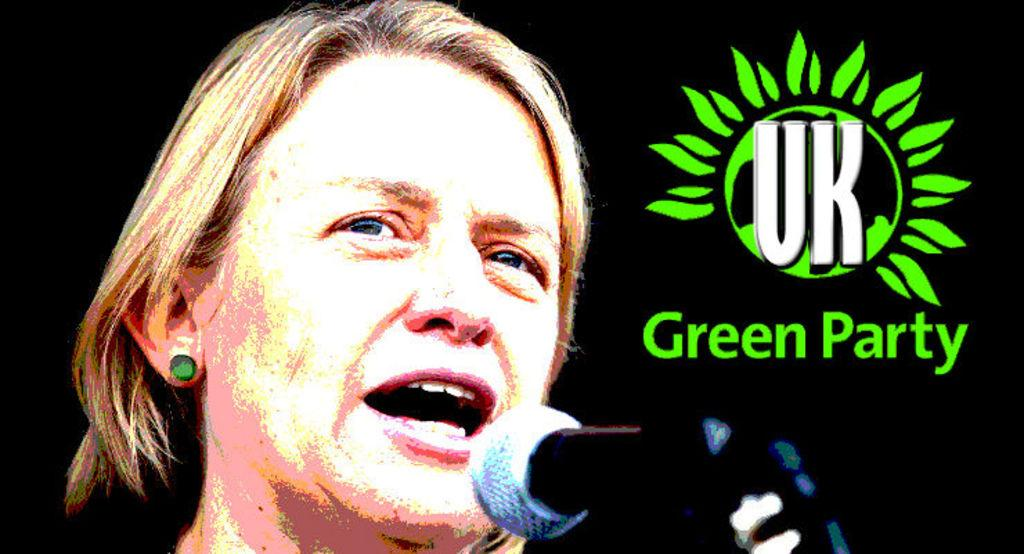What is the woman doing in the image? The woman is standing and speaking in the image. What object is in front of the woman? There is a microphone in front of the woman. What color is the logo on the right side of the image? The logo is green. How many cannons are visible in the image? There are no cannons present in the image. Can you describe the person jumping in the image? There is no person jumping in the image. 